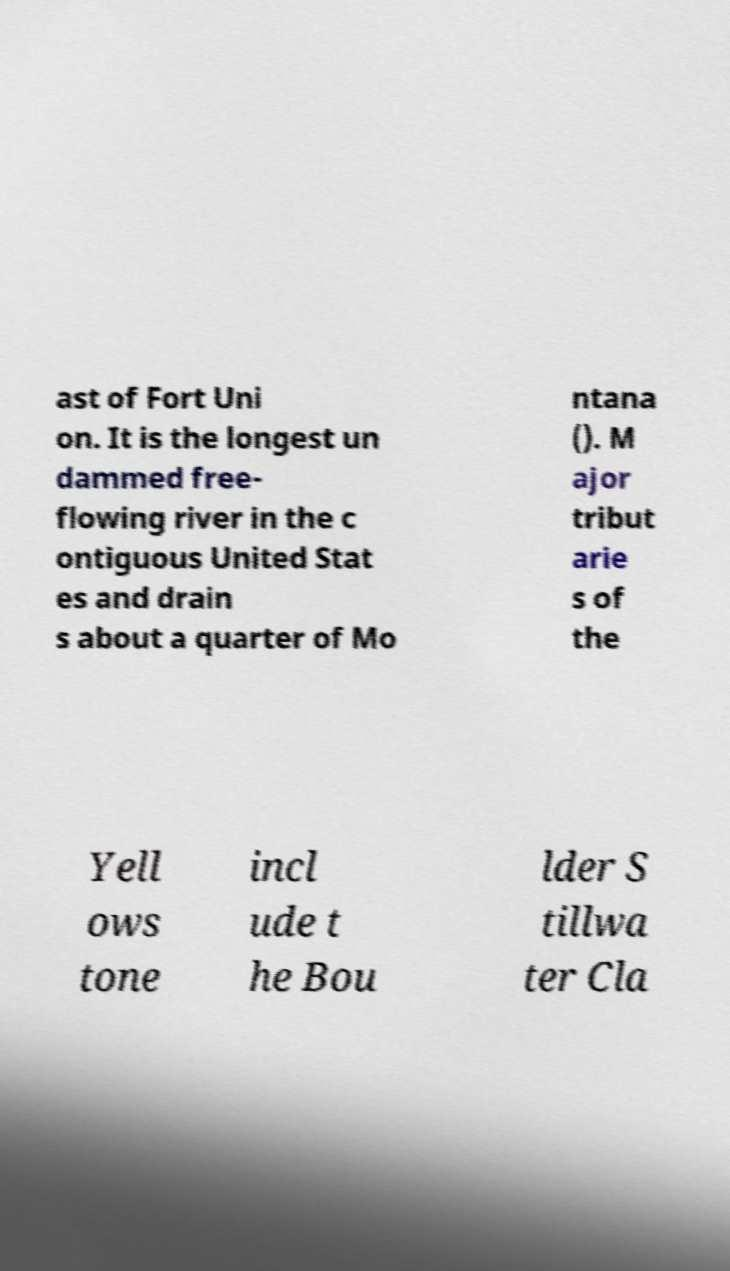Can you read and provide the text displayed in the image?This photo seems to have some interesting text. Can you extract and type it out for me? ast of Fort Uni on. It is the longest un dammed free- flowing river in the c ontiguous United Stat es and drain s about a quarter of Mo ntana (). M ajor tribut arie s of the Yell ows tone incl ude t he Bou lder S tillwa ter Cla 